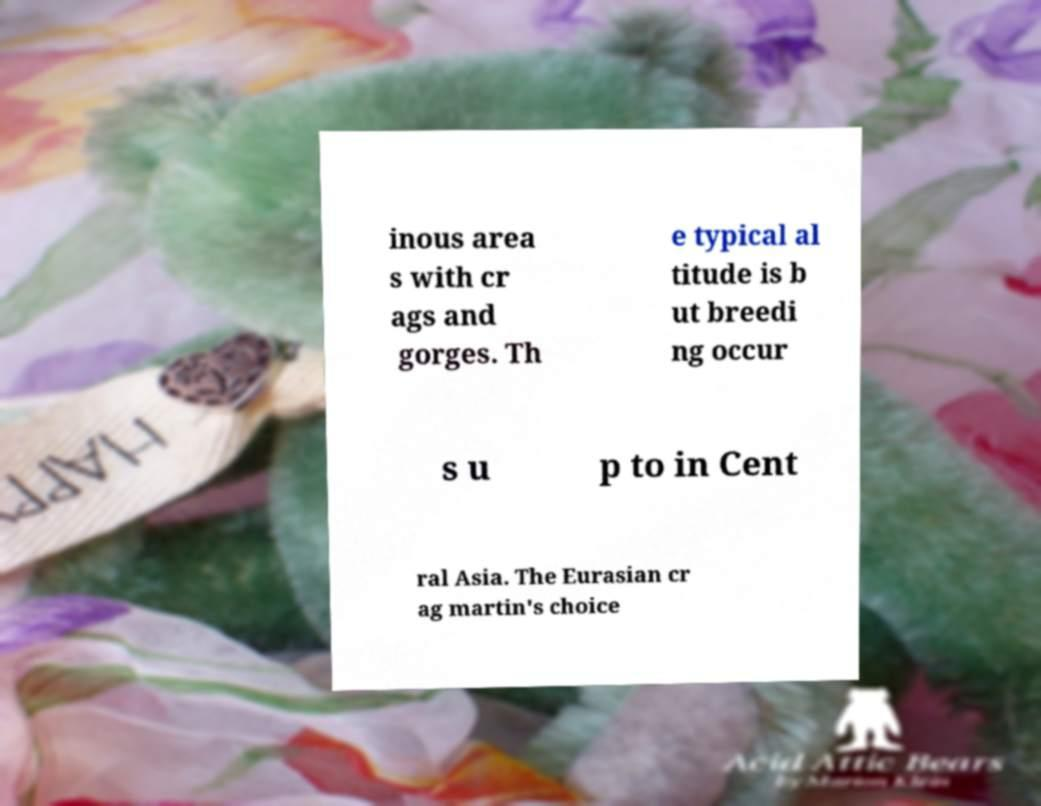For documentation purposes, I need the text within this image transcribed. Could you provide that? inous area s with cr ags and gorges. Th e typical al titude is b ut breedi ng occur s u p to in Cent ral Asia. The Eurasian cr ag martin's choice 